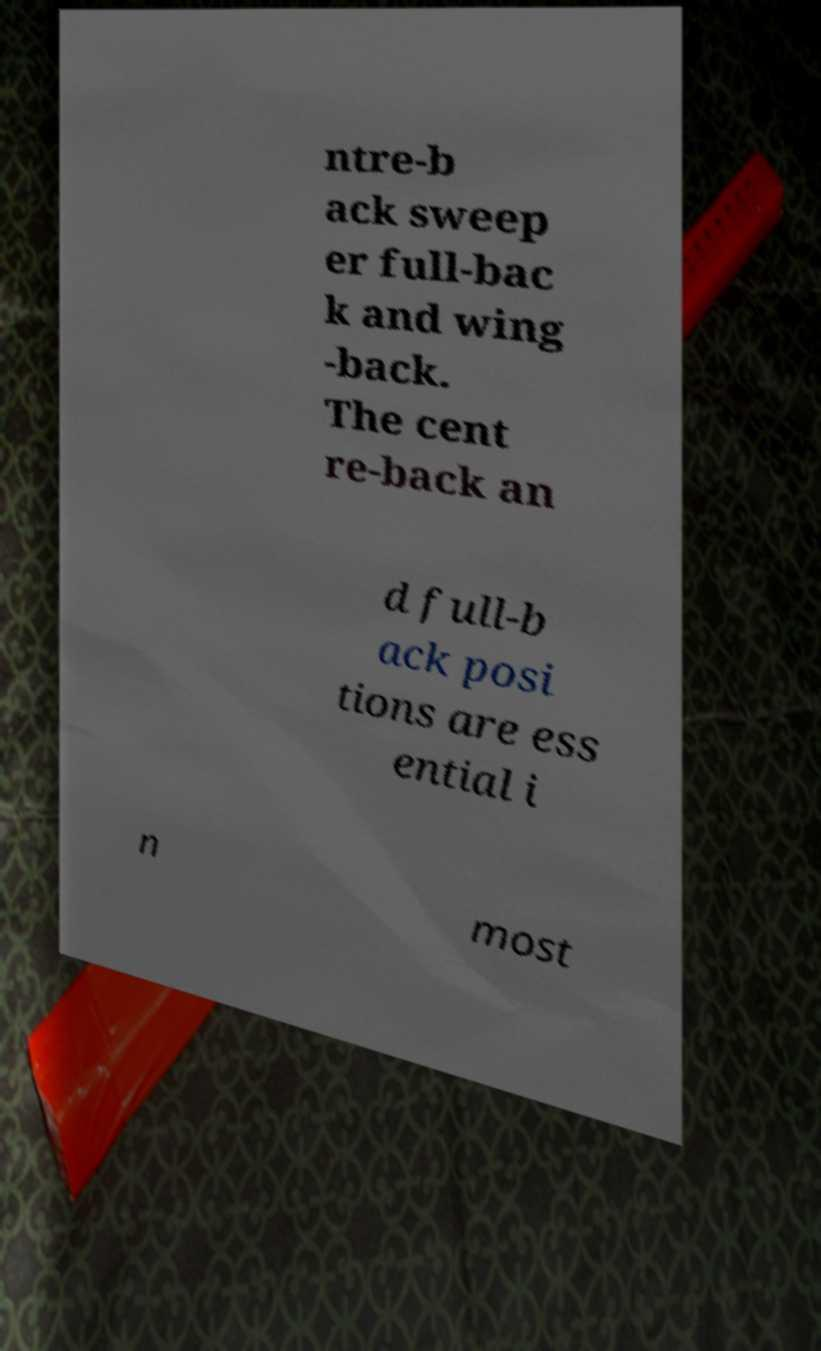I need the written content from this picture converted into text. Can you do that? ntre-b ack sweep er full-bac k and wing -back. The cent re-back an d full-b ack posi tions are ess ential i n most 